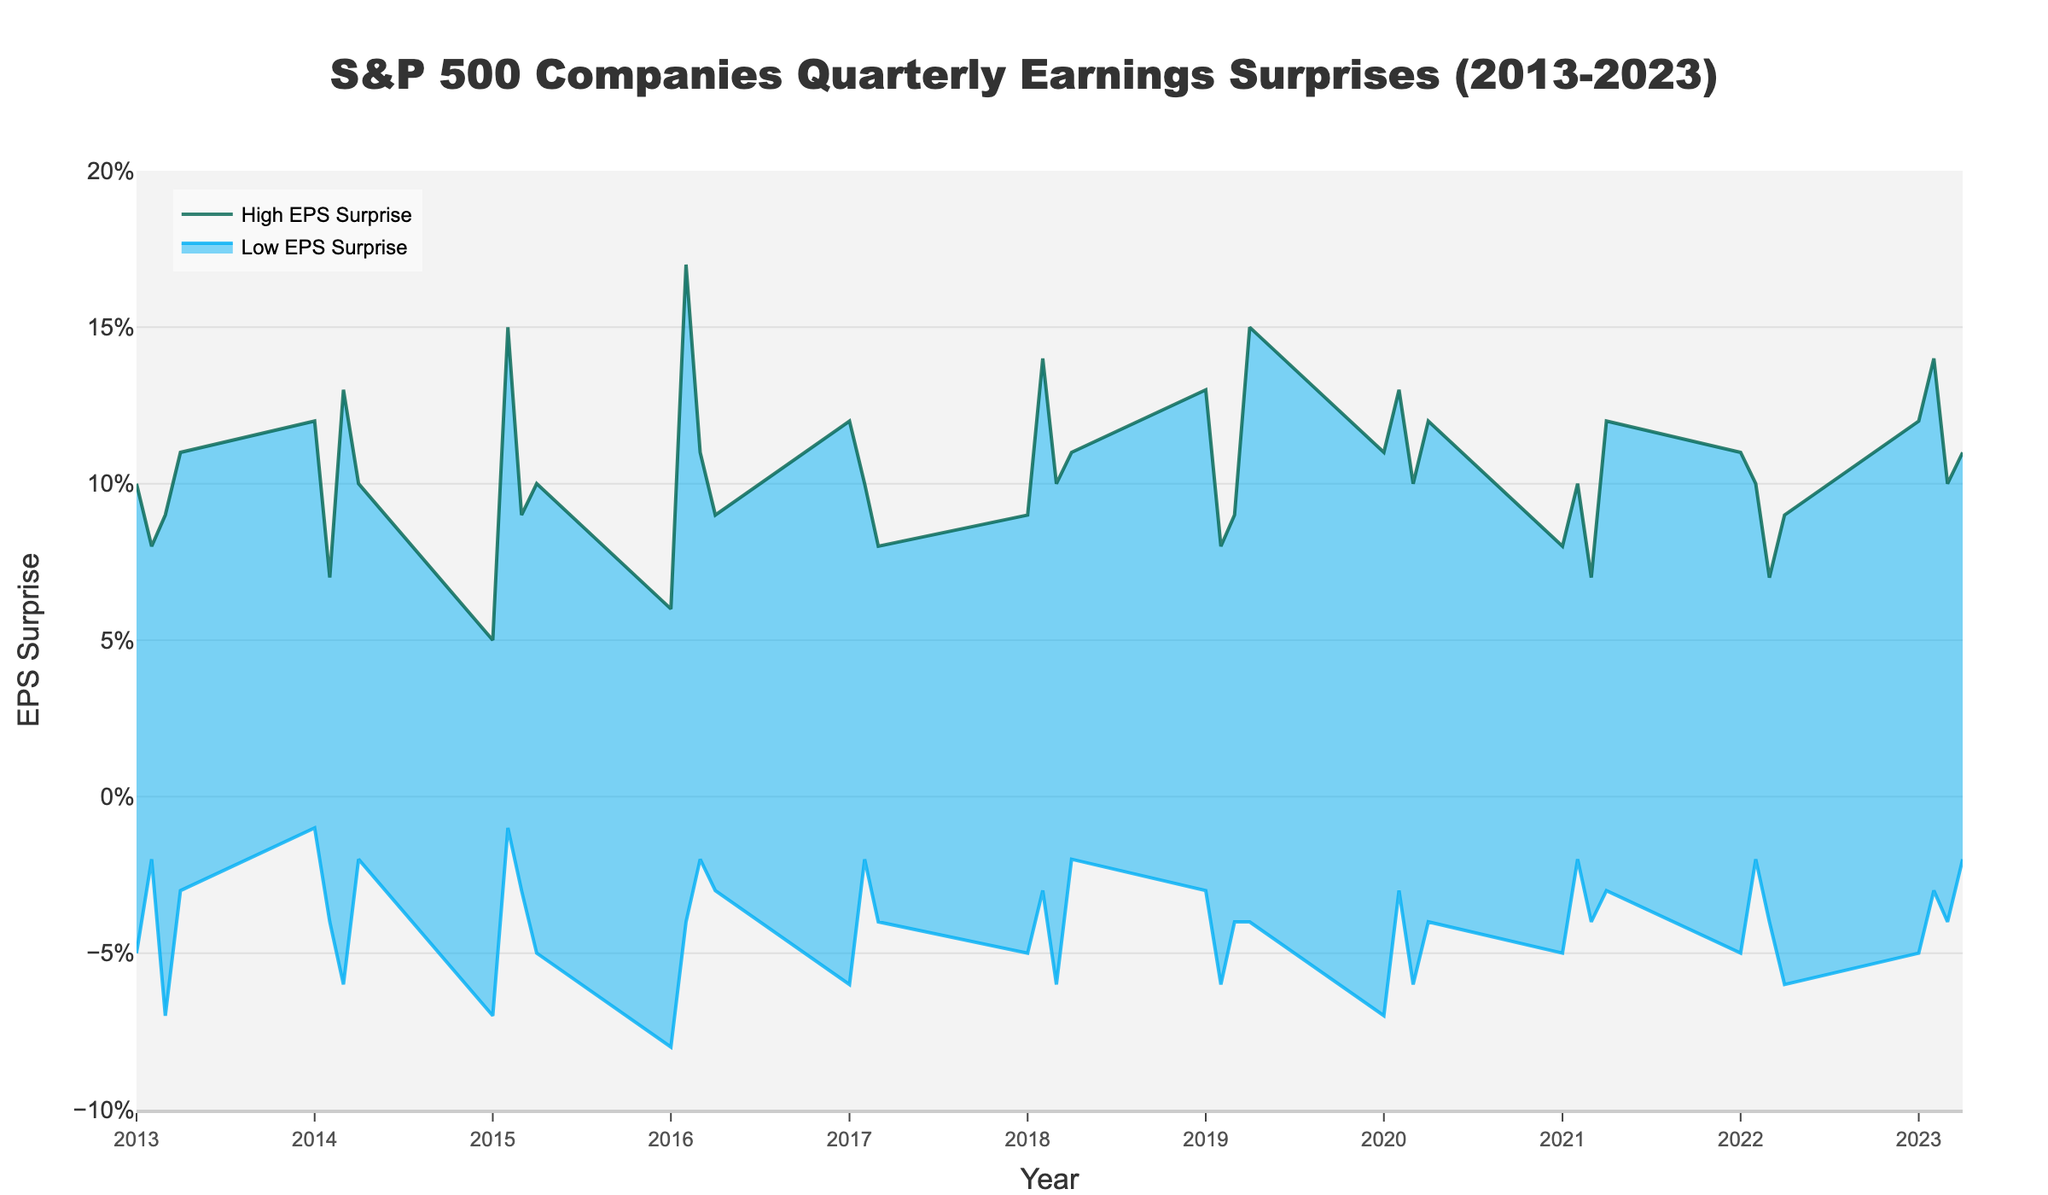What is the title of the figure? The title of the figure is located at the top and clearly describes the content.
Answer: S&P 500 Companies Quarterly Earnings Surprises (2013-2023) What is the range of EPS surprises for Netflix Inc. in Q2 2016? Look for the data point on the x-axis corresponding to Q2 2016 and examine the High and Low EPS Surprise values.
Answer: -0.04 to 0.17 During which quarter and year did Mastercard Inc. achieve its highest EPS surprise? Identify the highest point on the 'High EPS Surprise' line and trace it back to the corresponding quarter and year on the x-axis.
Answer: Q2 2018 How does the EPS range for Tesla Inc. in Q4 2019 compare to the range for NVIDIA Corp. in Q2 2020? Locate the EPS ranges for both companies and compare the high and low values. Tesla Inc. has a wider range.
Answer: Tesla Inc. has a wider range What trend do we observe in the high EPS surprises from 2016 to 2020? Look at the 'High EPS Surprise' line over these years and describe the tendency whether it’s increasing, decreasing, or fluctuating.
Answer: Fluctuating with peaks in certain quarters Which year and quarter had the highest low EPS surprise? Look for the tallest point on the 'Low EPS Surprise' line and check the corresponding year and quarter on the x-axis.
Answer: Q2 2016 Which company had the lowest EPS surprise in Q1 2016? Find the data point for Q1 2016 and look at the 'Low EPS Surprise' value for the company listed.
Answer: Coca-Cola Co Between Google LLC in Q4 2013 and Facebook Inc. (Meta) in Q3 2023, which had a higher high EPS surprise? Compare the 'High EPS Surprise' values of these two data points.
Answer: Google LLC What is the general pattern of low EPS surprises over the years? Examine the pattern of 'Low EPS Surprise' values by following its line through the entire period.
Answer: Generally fluctuating with significant drops in some periods 